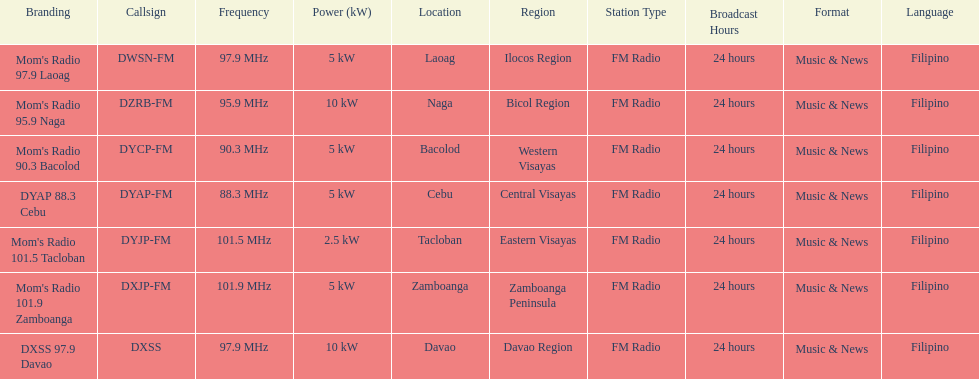Which of these stations broadcasts with the least power? Mom's Radio 101.5 Tacloban. 